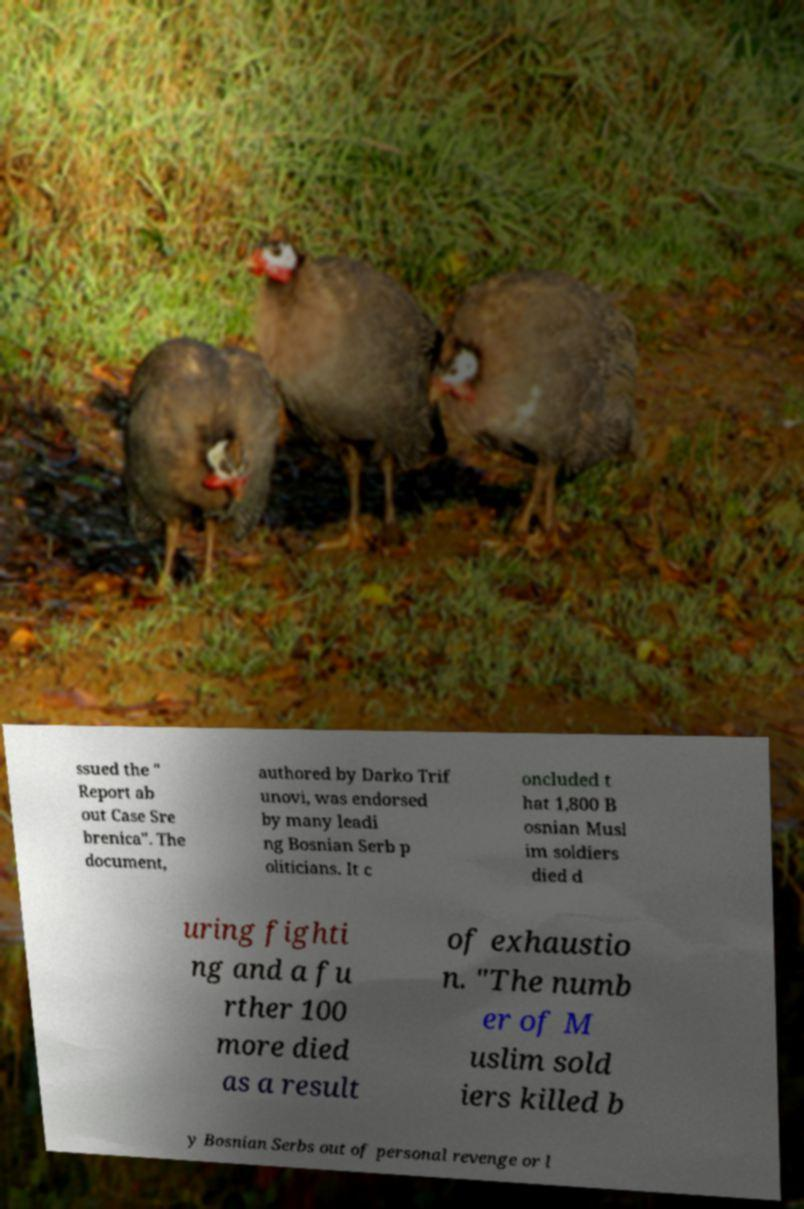There's text embedded in this image that I need extracted. Can you transcribe it verbatim? ssued the " Report ab out Case Sre brenica". The document, authored by Darko Trif unovi, was endorsed by many leadi ng Bosnian Serb p oliticians. It c oncluded t hat 1,800 B osnian Musl im soldiers died d uring fighti ng and a fu rther 100 more died as a result of exhaustio n. "The numb er of M uslim sold iers killed b y Bosnian Serbs out of personal revenge or l 